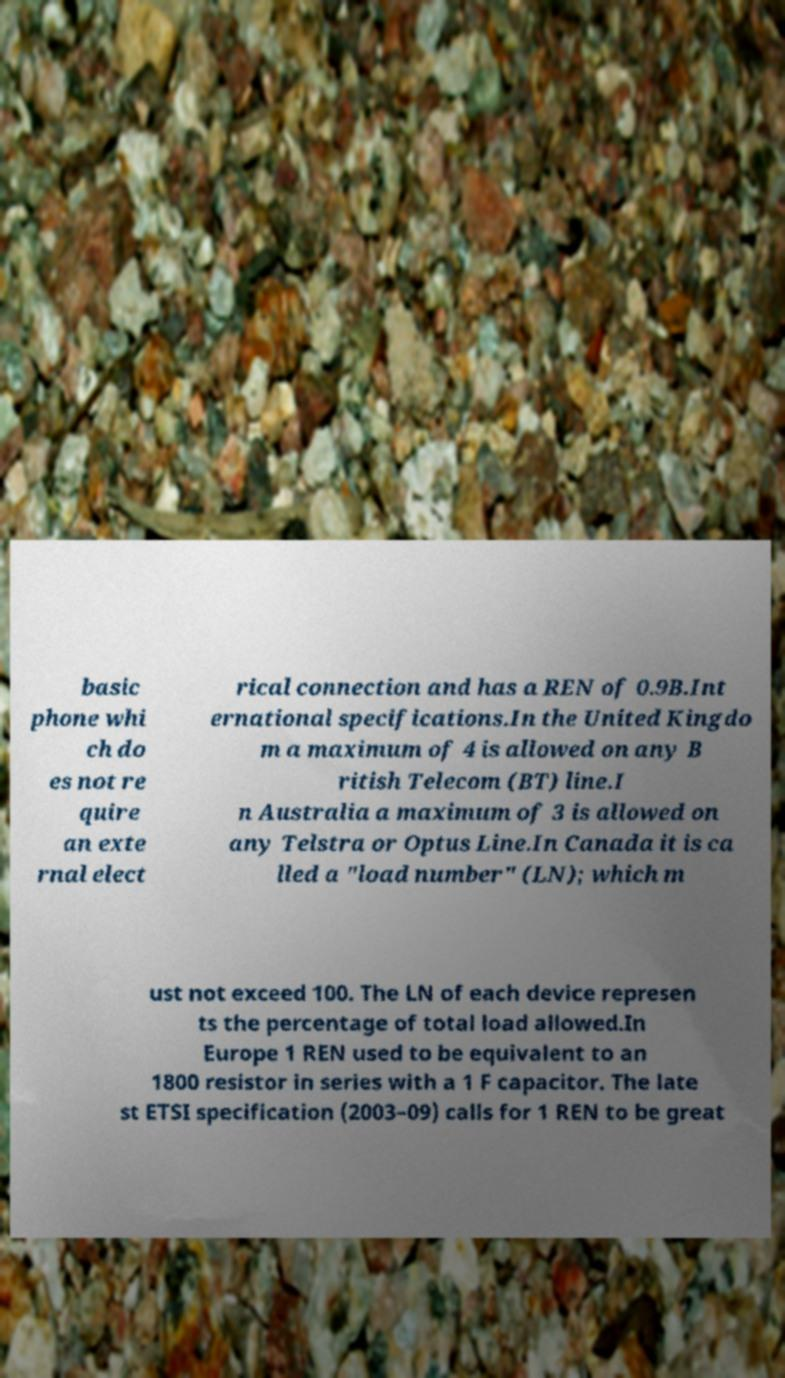Can you read and provide the text displayed in the image?This photo seems to have some interesting text. Can you extract and type it out for me? basic phone whi ch do es not re quire an exte rnal elect rical connection and has a REN of 0.9B.Int ernational specifications.In the United Kingdo m a maximum of 4 is allowed on any B ritish Telecom (BT) line.I n Australia a maximum of 3 is allowed on any Telstra or Optus Line.In Canada it is ca lled a "load number" (LN); which m ust not exceed 100. The LN of each device represen ts the percentage of total load allowed.In Europe 1 REN used to be equivalent to an 1800 resistor in series with a 1 F capacitor. The late st ETSI specification (2003–09) calls for 1 REN to be great 